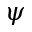Convert formula to latex. <formula><loc_0><loc_0><loc_500><loc_500>\psi</formula> 